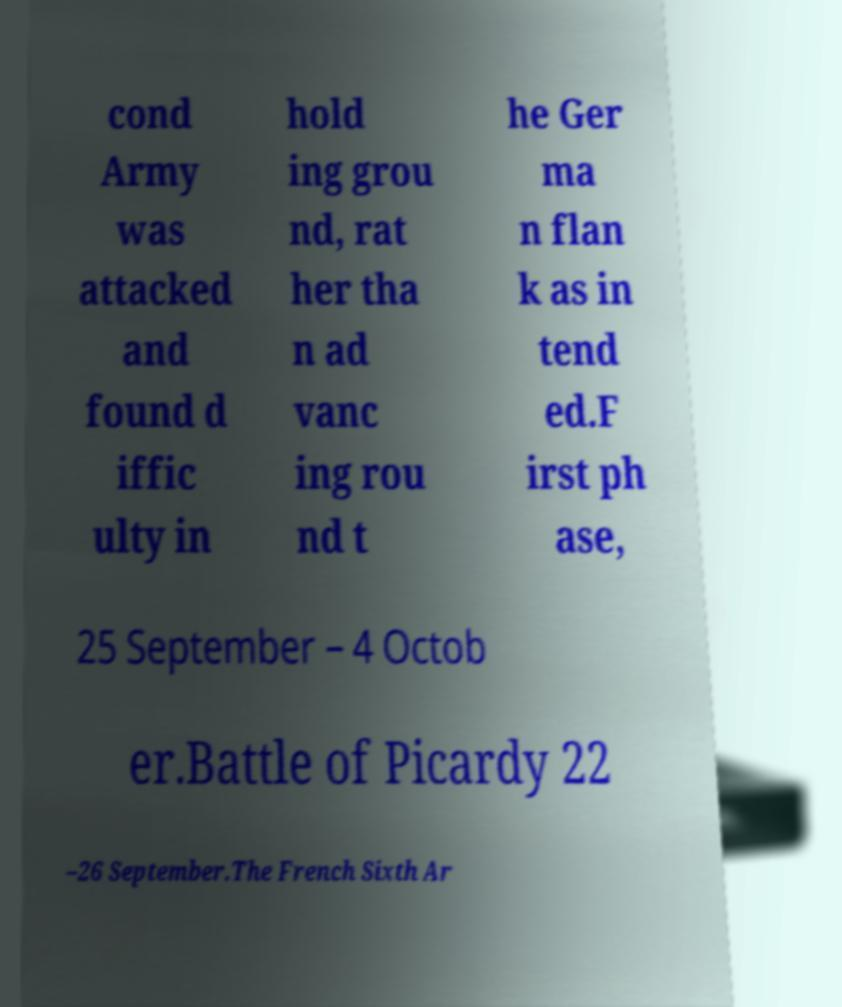What messages or text are displayed in this image? I need them in a readable, typed format. cond Army was attacked and found d iffic ulty in hold ing grou nd, rat her tha n ad vanc ing rou nd t he Ger ma n flan k as in tend ed.F irst ph ase, 25 September – 4 Octob er.Battle of Picardy 22 –26 September.The French Sixth Ar 